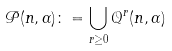<formula> <loc_0><loc_0><loc_500><loc_500>\mathcal { P } ( n , \alpha ) \colon = \bigcup _ { r \geq 0 } \mathcal { Q } ^ { r } ( n , \alpha )</formula> 